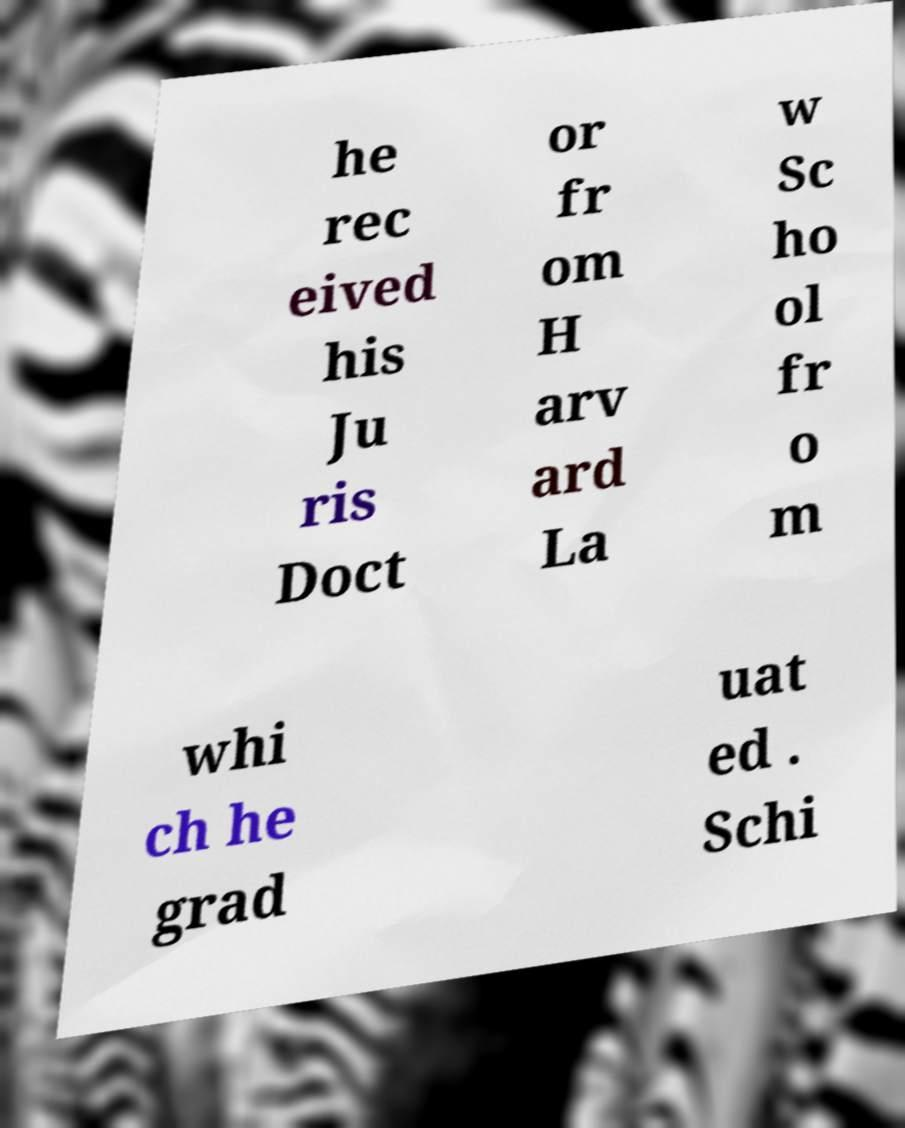Please read and relay the text visible in this image. What does it say? he rec eived his Ju ris Doct or fr om H arv ard La w Sc ho ol fr o m whi ch he grad uat ed . Schi 